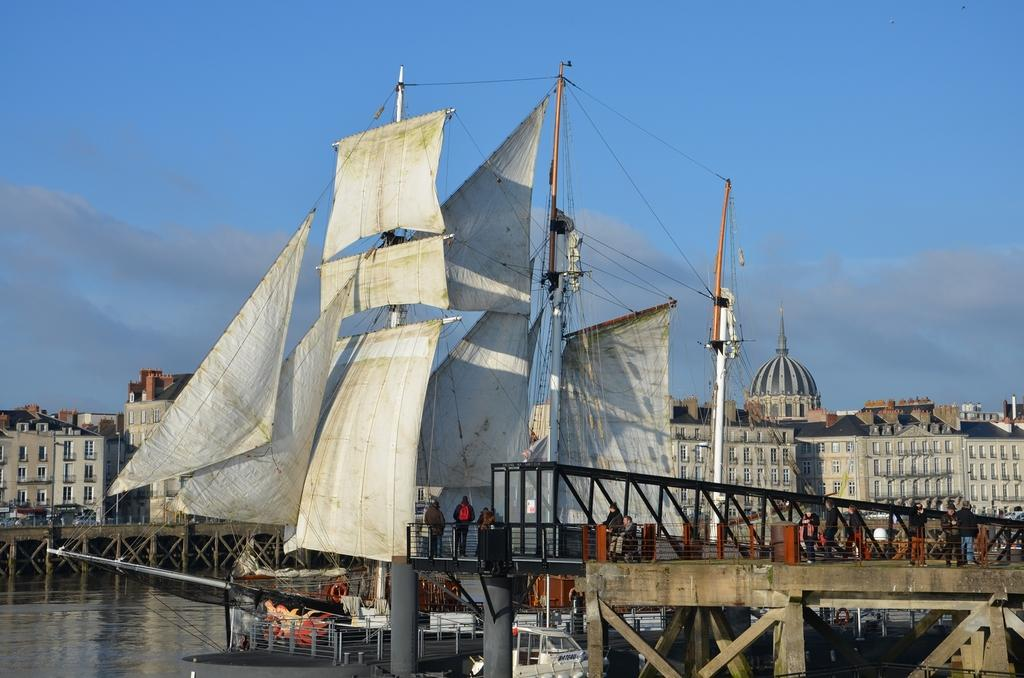What can be seen in the sky in the image? The sky with clouds is visible in the image. What type of structures are present in the image? There are buildings and bridges in the image. What is on the water in the image? Ships are on the water in the image. What are the persons in the image doing? Persons are standing on the bridge in the image. What type of cushion is being used as an invention in the image? There is no cushion or invention present in the image. Where is the office located in the image? There is no office present in the image. 